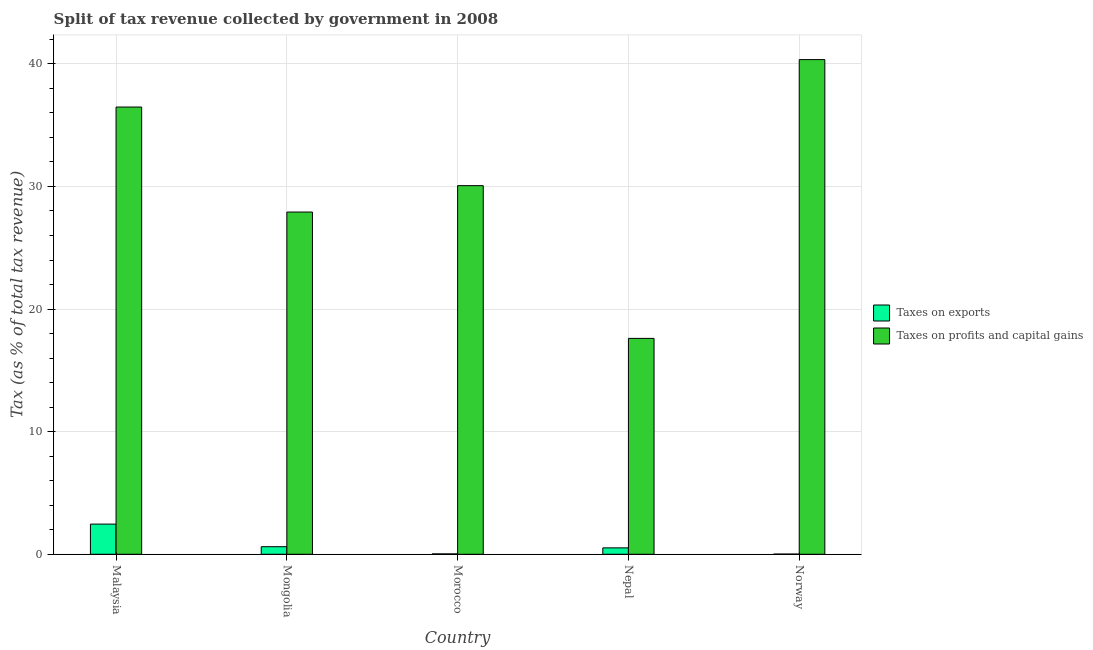How many different coloured bars are there?
Make the answer very short. 2. Are the number of bars per tick equal to the number of legend labels?
Offer a very short reply. Yes. How many bars are there on the 2nd tick from the right?
Make the answer very short. 2. What is the label of the 3rd group of bars from the left?
Offer a very short reply. Morocco. What is the percentage of revenue obtained from taxes on profits and capital gains in Norway?
Your answer should be very brief. 40.35. Across all countries, what is the maximum percentage of revenue obtained from taxes on exports?
Ensure brevity in your answer.  2.46. Across all countries, what is the minimum percentage of revenue obtained from taxes on profits and capital gains?
Make the answer very short. 17.61. In which country was the percentage of revenue obtained from taxes on exports minimum?
Your answer should be compact. Norway. What is the total percentage of revenue obtained from taxes on exports in the graph?
Your response must be concise. 3.65. What is the difference between the percentage of revenue obtained from taxes on exports in Mongolia and that in Morocco?
Your response must be concise. 0.59. What is the difference between the percentage of revenue obtained from taxes on profits and capital gains in Malaysia and the percentage of revenue obtained from taxes on exports in Morocco?
Keep it short and to the point. 36.45. What is the average percentage of revenue obtained from taxes on profits and capital gains per country?
Keep it short and to the point. 30.48. What is the difference between the percentage of revenue obtained from taxes on profits and capital gains and percentage of revenue obtained from taxes on exports in Morocco?
Keep it short and to the point. 30.03. What is the ratio of the percentage of revenue obtained from taxes on profits and capital gains in Mongolia to that in Nepal?
Give a very brief answer. 1.59. Is the percentage of revenue obtained from taxes on exports in Nepal less than that in Norway?
Keep it short and to the point. No. What is the difference between the highest and the second highest percentage of revenue obtained from taxes on exports?
Your response must be concise. 1.84. What is the difference between the highest and the lowest percentage of revenue obtained from taxes on profits and capital gains?
Offer a terse response. 22.74. In how many countries, is the percentage of revenue obtained from taxes on exports greater than the average percentage of revenue obtained from taxes on exports taken over all countries?
Your answer should be very brief. 1. What does the 2nd bar from the left in Nepal represents?
Provide a succinct answer. Taxes on profits and capital gains. What does the 2nd bar from the right in Malaysia represents?
Make the answer very short. Taxes on exports. How many bars are there?
Offer a very short reply. 10. Are all the bars in the graph horizontal?
Your answer should be very brief. No. How many legend labels are there?
Keep it short and to the point. 2. What is the title of the graph?
Provide a succinct answer. Split of tax revenue collected by government in 2008. What is the label or title of the X-axis?
Provide a succinct answer. Country. What is the label or title of the Y-axis?
Provide a short and direct response. Tax (as % of total tax revenue). What is the Tax (as % of total tax revenue) in Taxes on exports in Malaysia?
Give a very brief answer. 2.46. What is the Tax (as % of total tax revenue) of Taxes on profits and capital gains in Malaysia?
Your response must be concise. 36.48. What is the Tax (as % of total tax revenue) of Taxes on exports in Mongolia?
Make the answer very short. 0.62. What is the Tax (as % of total tax revenue) in Taxes on profits and capital gains in Mongolia?
Ensure brevity in your answer.  27.91. What is the Tax (as % of total tax revenue) of Taxes on exports in Morocco?
Provide a succinct answer. 0.03. What is the Tax (as % of total tax revenue) in Taxes on profits and capital gains in Morocco?
Your response must be concise. 30.07. What is the Tax (as % of total tax revenue) in Taxes on exports in Nepal?
Your answer should be compact. 0.52. What is the Tax (as % of total tax revenue) of Taxes on profits and capital gains in Nepal?
Offer a terse response. 17.61. What is the Tax (as % of total tax revenue) in Taxes on exports in Norway?
Offer a very short reply. 0.02. What is the Tax (as % of total tax revenue) in Taxes on profits and capital gains in Norway?
Provide a short and direct response. 40.35. Across all countries, what is the maximum Tax (as % of total tax revenue) in Taxes on exports?
Offer a terse response. 2.46. Across all countries, what is the maximum Tax (as % of total tax revenue) in Taxes on profits and capital gains?
Keep it short and to the point. 40.35. Across all countries, what is the minimum Tax (as % of total tax revenue) of Taxes on exports?
Offer a very short reply. 0.02. Across all countries, what is the minimum Tax (as % of total tax revenue) in Taxes on profits and capital gains?
Your response must be concise. 17.61. What is the total Tax (as % of total tax revenue) in Taxes on exports in the graph?
Your answer should be very brief. 3.65. What is the total Tax (as % of total tax revenue) in Taxes on profits and capital gains in the graph?
Keep it short and to the point. 152.42. What is the difference between the Tax (as % of total tax revenue) of Taxes on exports in Malaysia and that in Mongolia?
Ensure brevity in your answer.  1.84. What is the difference between the Tax (as % of total tax revenue) in Taxes on profits and capital gains in Malaysia and that in Mongolia?
Keep it short and to the point. 8.56. What is the difference between the Tax (as % of total tax revenue) in Taxes on exports in Malaysia and that in Morocco?
Provide a succinct answer. 2.43. What is the difference between the Tax (as % of total tax revenue) of Taxes on profits and capital gains in Malaysia and that in Morocco?
Ensure brevity in your answer.  6.41. What is the difference between the Tax (as % of total tax revenue) of Taxes on exports in Malaysia and that in Nepal?
Offer a terse response. 1.94. What is the difference between the Tax (as % of total tax revenue) of Taxes on profits and capital gains in Malaysia and that in Nepal?
Your response must be concise. 18.87. What is the difference between the Tax (as % of total tax revenue) in Taxes on exports in Malaysia and that in Norway?
Make the answer very short. 2.44. What is the difference between the Tax (as % of total tax revenue) of Taxes on profits and capital gains in Malaysia and that in Norway?
Offer a terse response. -3.87. What is the difference between the Tax (as % of total tax revenue) of Taxes on exports in Mongolia and that in Morocco?
Your response must be concise. 0.59. What is the difference between the Tax (as % of total tax revenue) in Taxes on profits and capital gains in Mongolia and that in Morocco?
Provide a succinct answer. -2.15. What is the difference between the Tax (as % of total tax revenue) of Taxes on exports in Mongolia and that in Nepal?
Offer a very short reply. 0.1. What is the difference between the Tax (as % of total tax revenue) in Taxes on profits and capital gains in Mongolia and that in Nepal?
Provide a succinct answer. 10.3. What is the difference between the Tax (as % of total tax revenue) in Taxes on exports in Mongolia and that in Norway?
Ensure brevity in your answer.  0.6. What is the difference between the Tax (as % of total tax revenue) in Taxes on profits and capital gains in Mongolia and that in Norway?
Ensure brevity in your answer.  -12.43. What is the difference between the Tax (as % of total tax revenue) in Taxes on exports in Morocco and that in Nepal?
Ensure brevity in your answer.  -0.49. What is the difference between the Tax (as % of total tax revenue) of Taxes on profits and capital gains in Morocco and that in Nepal?
Your response must be concise. 12.46. What is the difference between the Tax (as % of total tax revenue) of Taxes on exports in Morocco and that in Norway?
Give a very brief answer. 0.02. What is the difference between the Tax (as % of total tax revenue) of Taxes on profits and capital gains in Morocco and that in Norway?
Give a very brief answer. -10.28. What is the difference between the Tax (as % of total tax revenue) of Taxes on exports in Nepal and that in Norway?
Provide a succinct answer. 0.51. What is the difference between the Tax (as % of total tax revenue) of Taxes on profits and capital gains in Nepal and that in Norway?
Give a very brief answer. -22.74. What is the difference between the Tax (as % of total tax revenue) of Taxes on exports in Malaysia and the Tax (as % of total tax revenue) of Taxes on profits and capital gains in Mongolia?
Keep it short and to the point. -25.45. What is the difference between the Tax (as % of total tax revenue) of Taxes on exports in Malaysia and the Tax (as % of total tax revenue) of Taxes on profits and capital gains in Morocco?
Provide a short and direct response. -27.61. What is the difference between the Tax (as % of total tax revenue) of Taxes on exports in Malaysia and the Tax (as % of total tax revenue) of Taxes on profits and capital gains in Nepal?
Make the answer very short. -15.15. What is the difference between the Tax (as % of total tax revenue) in Taxes on exports in Malaysia and the Tax (as % of total tax revenue) in Taxes on profits and capital gains in Norway?
Offer a very short reply. -37.89. What is the difference between the Tax (as % of total tax revenue) in Taxes on exports in Mongolia and the Tax (as % of total tax revenue) in Taxes on profits and capital gains in Morocco?
Provide a succinct answer. -29.45. What is the difference between the Tax (as % of total tax revenue) of Taxes on exports in Mongolia and the Tax (as % of total tax revenue) of Taxes on profits and capital gains in Nepal?
Ensure brevity in your answer.  -16.99. What is the difference between the Tax (as % of total tax revenue) in Taxes on exports in Mongolia and the Tax (as % of total tax revenue) in Taxes on profits and capital gains in Norway?
Keep it short and to the point. -39.73. What is the difference between the Tax (as % of total tax revenue) of Taxes on exports in Morocco and the Tax (as % of total tax revenue) of Taxes on profits and capital gains in Nepal?
Your response must be concise. -17.58. What is the difference between the Tax (as % of total tax revenue) in Taxes on exports in Morocco and the Tax (as % of total tax revenue) in Taxes on profits and capital gains in Norway?
Make the answer very short. -40.32. What is the difference between the Tax (as % of total tax revenue) in Taxes on exports in Nepal and the Tax (as % of total tax revenue) in Taxes on profits and capital gains in Norway?
Offer a terse response. -39.82. What is the average Tax (as % of total tax revenue) in Taxes on exports per country?
Provide a succinct answer. 0.73. What is the average Tax (as % of total tax revenue) of Taxes on profits and capital gains per country?
Provide a succinct answer. 30.48. What is the difference between the Tax (as % of total tax revenue) of Taxes on exports and Tax (as % of total tax revenue) of Taxes on profits and capital gains in Malaysia?
Provide a succinct answer. -34.02. What is the difference between the Tax (as % of total tax revenue) in Taxes on exports and Tax (as % of total tax revenue) in Taxes on profits and capital gains in Mongolia?
Provide a succinct answer. -27.3. What is the difference between the Tax (as % of total tax revenue) in Taxes on exports and Tax (as % of total tax revenue) in Taxes on profits and capital gains in Morocco?
Ensure brevity in your answer.  -30.03. What is the difference between the Tax (as % of total tax revenue) in Taxes on exports and Tax (as % of total tax revenue) in Taxes on profits and capital gains in Nepal?
Provide a succinct answer. -17.09. What is the difference between the Tax (as % of total tax revenue) of Taxes on exports and Tax (as % of total tax revenue) of Taxes on profits and capital gains in Norway?
Your answer should be compact. -40.33. What is the ratio of the Tax (as % of total tax revenue) of Taxes on exports in Malaysia to that in Mongolia?
Offer a terse response. 3.98. What is the ratio of the Tax (as % of total tax revenue) in Taxes on profits and capital gains in Malaysia to that in Mongolia?
Ensure brevity in your answer.  1.31. What is the ratio of the Tax (as % of total tax revenue) of Taxes on exports in Malaysia to that in Morocco?
Offer a terse response. 75.26. What is the ratio of the Tax (as % of total tax revenue) of Taxes on profits and capital gains in Malaysia to that in Morocco?
Your answer should be compact. 1.21. What is the ratio of the Tax (as % of total tax revenue) in Taxes on exports in Malaysia to that in Nepal?
Your response must be concise. 4.7. What is the ratio of the Tax (as % of total tax revenue) in Taxes on profits and capital gains in Malaysia to that in Nepal?
Offer a terse response. 2.07. What is the ratio of the Tax (as % of total tax revenue) in Taxes on exports in Malaysia to that in Norway?
Make the answer very short. 148.41. What is the ratio of the Tax (as % of total tax revenue) in Taxes on profits and capital gains in Malaysia to that in Norway?
Offer a very short reply. 0.9. What is the ratio of the Tax (as % of total tax revenue) in Taxes on exports in Mongolia to that in Morocco?
Your response must be concise. 18.92. What is the ratio of the Tax (as % of total tax revenue) in Taxes on profits and capital gains in Mongolia to that in Morocco?
Give a very brief answer. 0.93. What is the ratio of the Tax (as % of total tax revenue) in Taxes on exports in Mongolia to that in Nepal?
Your answer should be very brief. 1.18. What is the ratio of the Tax (as % of total tax revenue) in Taxes on profits and capital gains in Mongolia to that in Nepal?
Your answer should be very brief. 1.59. What is the ratio of the Tax (as % of total tax revenue) in Taxes on exports in Mongolia to that in Norway?
Provide a succinct answer. 37.31. What is the ratio of the Tax (as % of total tax revenue) of Taxes on profits and capital gains in Mongolia to that in Norway?
Provide a short and direct response. 0.69. What is the ratio of the Tax (as % of total tax revenue) of Taxes on exports in Morocco to that in Nepal?
Offer a terse response. 0.06. What is the ratio of the Tax (as % of total tax revenue) in Taxes on profits and capital gains in Morocco to that in Nepal?
Offer a terse response. 1.71. What is the ratio of the Tax (as % of total tax revenue) in Taxes on exports in Morocco to that in Norway?
Make the answer very short. 1.97. What is the ratio of the Tax (as % of total tax revenue) in Taxes on profits and capital gains in Morocco to that in Norway?
Give a very brief answer. 0.75. What is the ratio of the Tax (as % of total tax revenue) of Taxes on exports in Nepal to that in Norway?
Keep it short and to the point. 31.55. What is the ratio of the Tax (as % of total tax revenue) in Taxes on profits and capital gains in Nepal to that in Norway?
Your answer should be compact. 0.44. What is the difference between the highest and the second highest Tax (as % of total tax revenue) in Taxes on exports?
Your answer should be very brief. 1.84. What is the difference between the highest and the second highest Tax (as % of total tax revenue) in Taxes on profits and capital gains?
Your answer should be compact. 3.87. What is the difference between the highest and the lowest Tax (as % of total tax revenue) of Taxes on exports?
Your answer should be very brief. 2.44. What is the difference between the highest and the lowest Tax (as % of total tax revenue) of Taxes on profits and capital gains?
Offer a terse response. 22.74. 